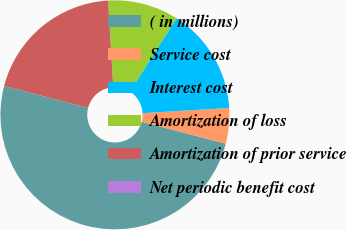Convert chart to OTSL. <chart><loc_0><loc_0><loc_500><loc_500><pie_chart><fcel>( in millions)<fcel>Service cost<fcel>Interest cost<fcel>Amortization of loss<fcel>Amortization of prior service<fcel>Net periodic benefit cost<nl><fcel>50.0%<fcel>5.0%<fcel>15.0%<fcel>10.0%<fcel>20.0%<fcel>0.0%<nl></chart> 